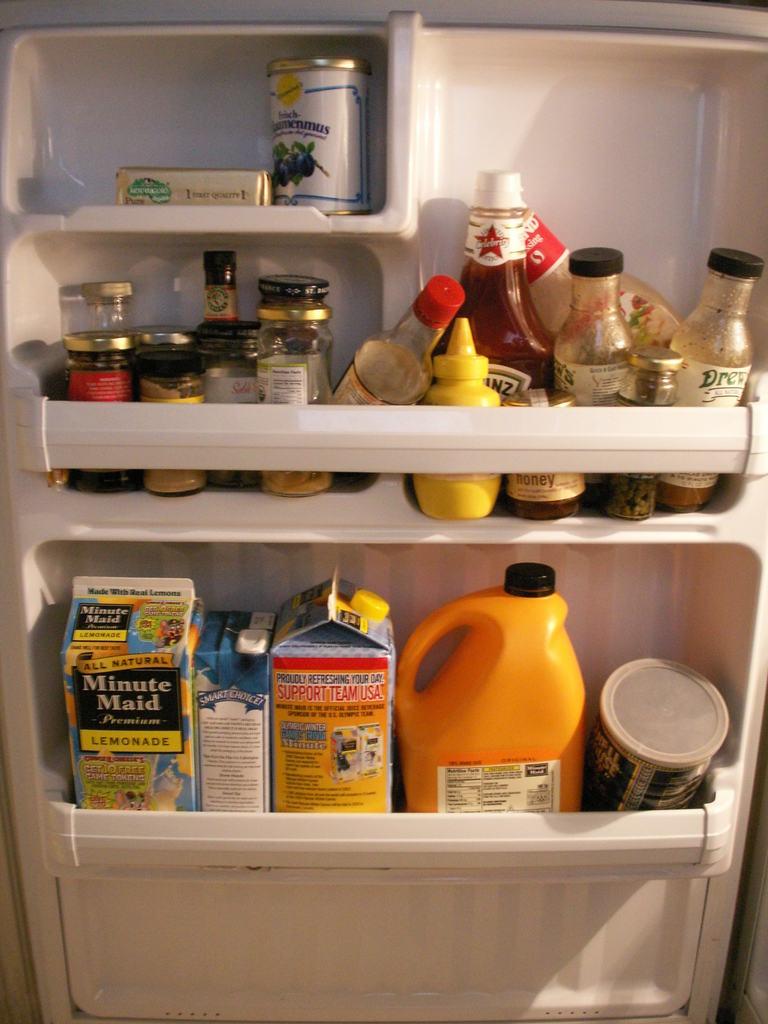What kind of juice is in the bottom left carton?
Make the answer very short. Lemonade. What team is one of the cartons asking you to support?
Your answer should be very brief. Team usa. 